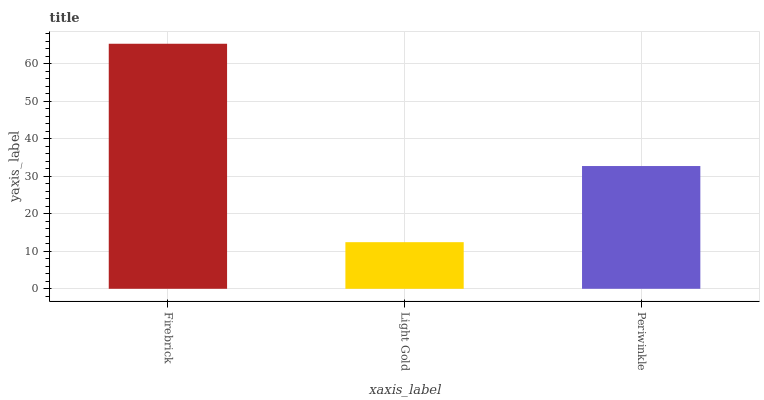Is Light Gold the minimum?
Answer yes or no. Yes. Is Firebrick the maximum?
Answer yes or no. Yes. Is Periwinkle the minimum?
Answer yes or no. No. Is Periwinkle the maximum?
Answer yes or no. No. Is Periwinkle greater than Light Gold?
Answer yes or no. Yes. Is Light Gold less than Periwinkle?
Answer yes or no. Yes. Is Light Gold greater than Periwinkle?
Answer yes or no. No. Is Periwinkle less than Light Gold?
Answer yes or no. No. Is Periwinkle the high median?
Answer yes or no. Yes. Is Periwinkle the low median?
Answer yes or no. Yes. Is Firebrick the high median?
Answer yes or no. No. Is Light Gold the low median?
Answer yes or no. No. 